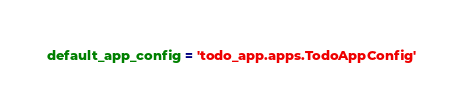Convert code to text. <code><loc_0><loc_0><loc_500><loc_500><_Python_>default_app_config = 'todo_app.apps.TodoAppConfig'

</code> 